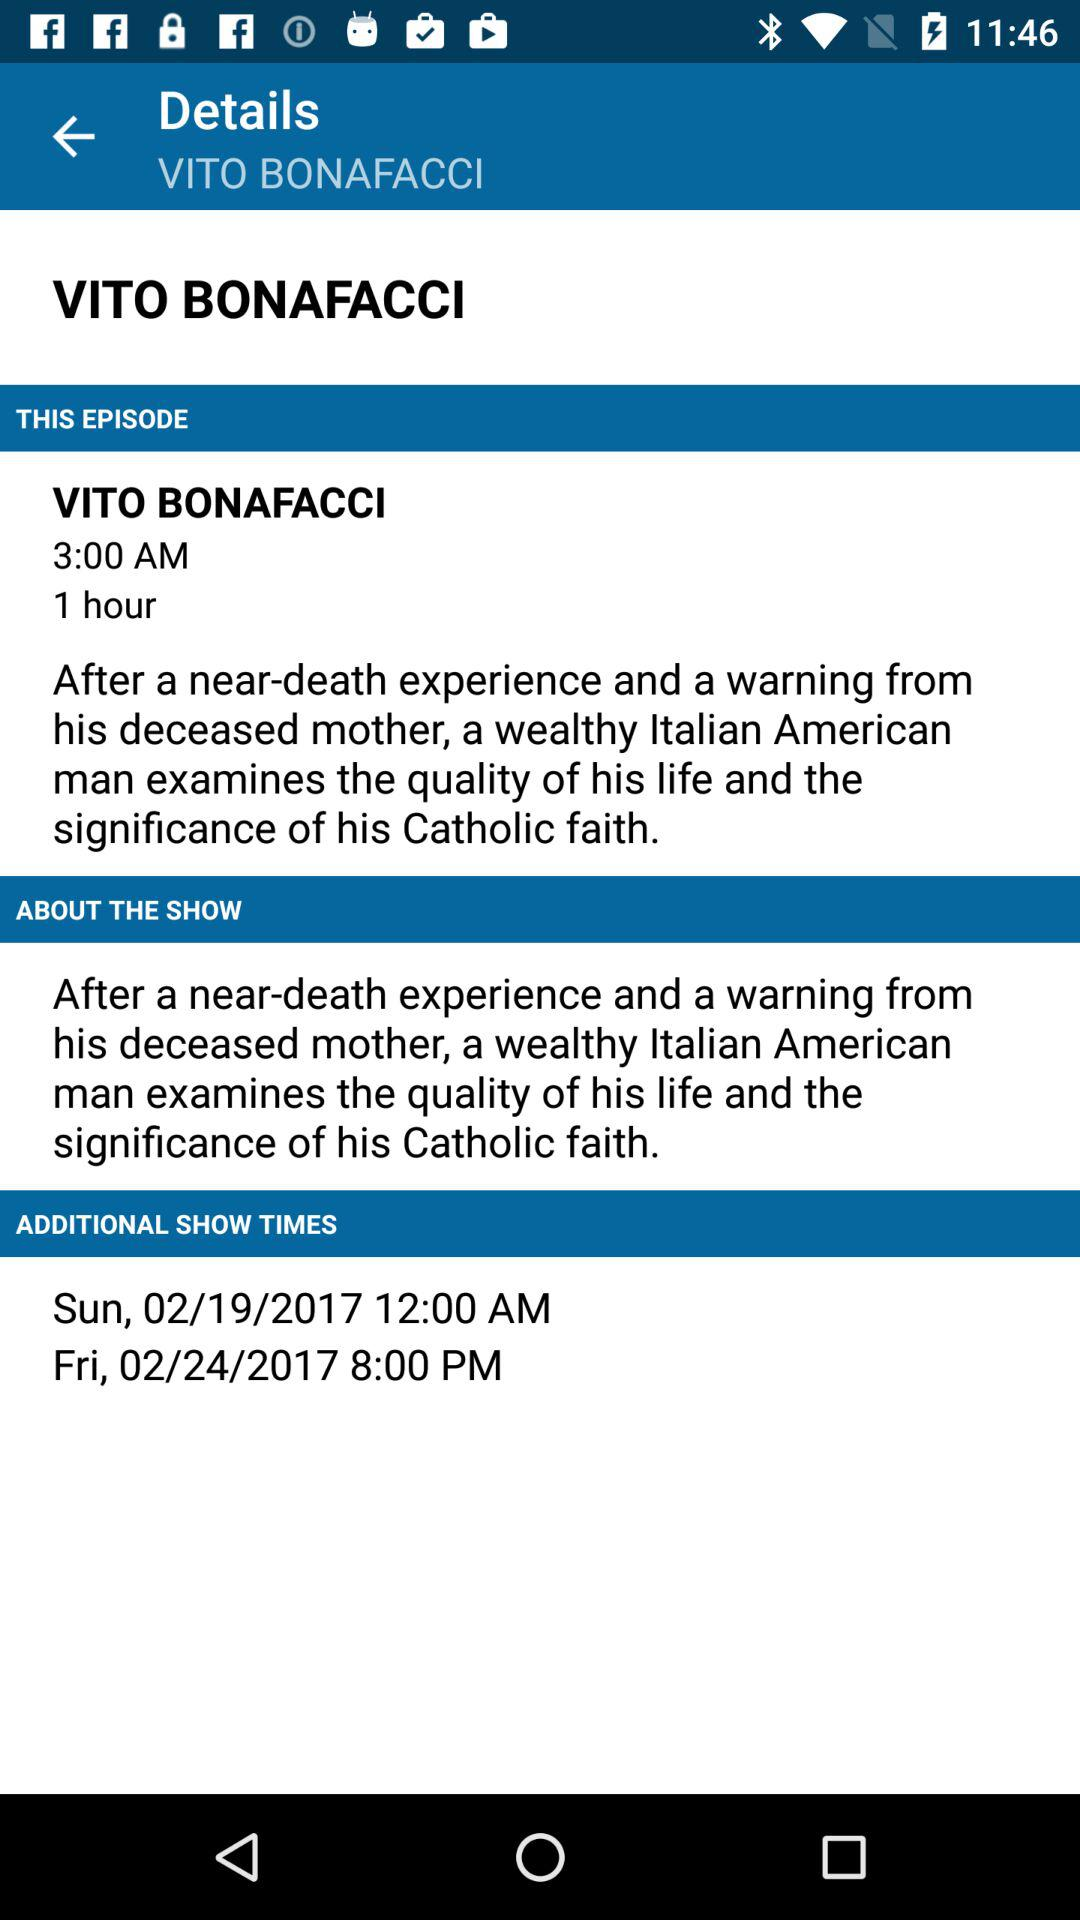What is the show time on Friday, February 24, 2017? The show time on Friday, February 24, 2017 is 8:00 PM. 